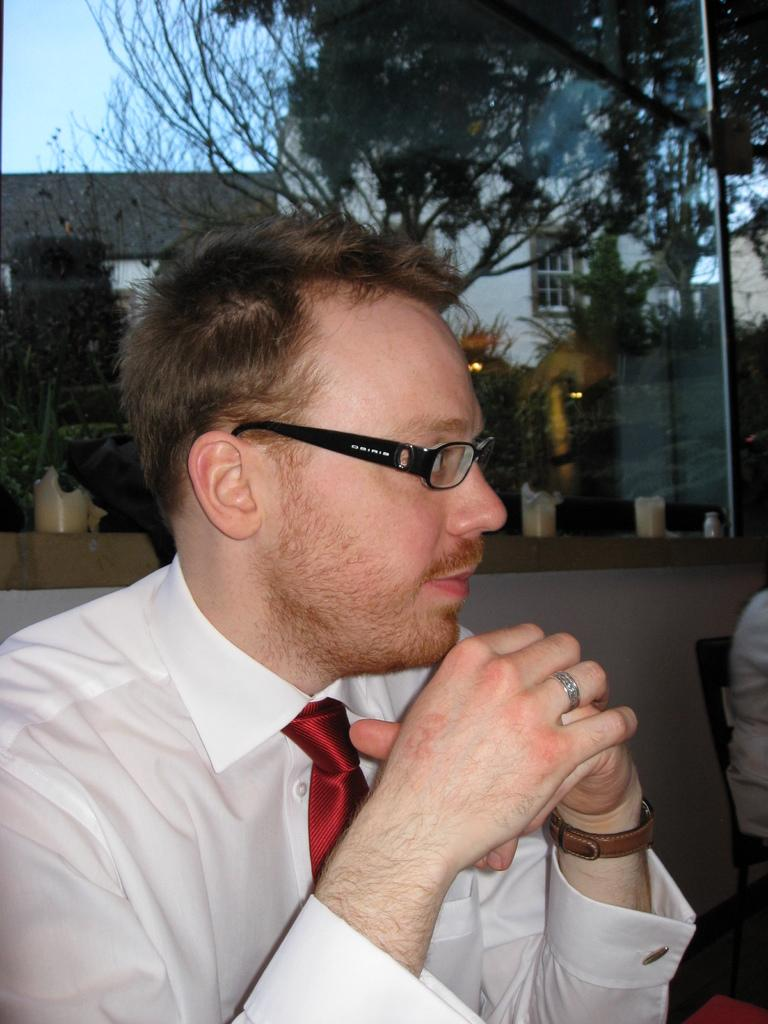What can be seen on the person's face in the image? There is a person with eyeglasses in the image. What type of structure is visible in the image? There is a glass window in the image. What is reflected in the glass window? The reflection of trees and buildings is visible in the window. What type of furniture is present in the image? There is a chair in the image. What level of substance is the governor seeking in the image? There is no governor or substance mentioned in the image; it features a person with eyeglasses, a glass window, and a chair. 